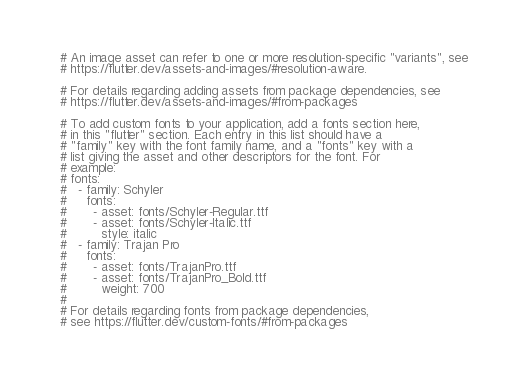<code> <loc_0><loc_0><loc_500><loc_500><_YAML_>  # An image asset can refer to one or more resolution-specific "variants", see
  # https://flutter.dev/assets-and-images/#resolution-aware.

  # For details regarding adding assets from package dependencies, see
  # https://flutter.dev/assets-and-images/#from-packages

  # To add custom fonts to your application, add a fonts section here,
  # in this "flutter" section. Each entry in this list should have a
  # "family" key with the font family name, and a "fonts" key with a
  # list giving the asset and other descriptors for the font. For
  # example:
  # fonts:
  #   - family: Schyler
  #     fonts:
  #       - asset: fonts/Schyler-Regular.ttf
  #       - asset: fonts/Schyler-Italic.ttf
  #         style: italic
  #   - family: Trajan Pro
  #     fonts:
  #       - asset: fonts/TrajanPro.ttf
  #       - asset: fonts/TrajanPro_Bold.ttf
  #         weight: 700
  #
  # For details regarding fonts from package dependencies,
  # see https://flutter.dev/custom-fonts/#from-packages
</code> 